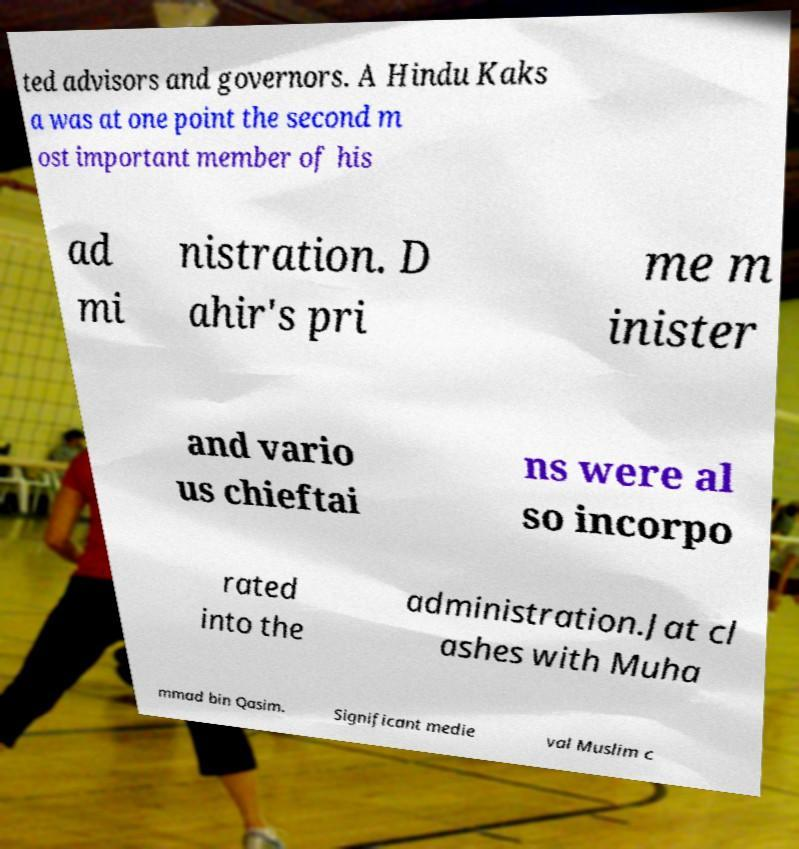Please read and relay the text visible in this image. What does it say? ted advisors and governors. A Hindu Kaks a was at one point the second m ost important member of his ad mi nistration. D ahir's pri me m inister and vario us chieftai ns were al so incorpo rated into the administration.Jat cl ashes with Muha mmad bin Qasim. Significant medie val Muslim c 